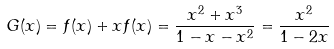Convert formula to latex. <formula><loc_0><loc_0><loc_500><loc_500>G ( x ) = f ( x ) + x f ( x ) = \frac { x ^ { 2 } + x ^ { 3 } } { 1 - x - x ^ { 2 } } = \frac { x ^ { 2 } } { 1 - 2 x }</formula> 